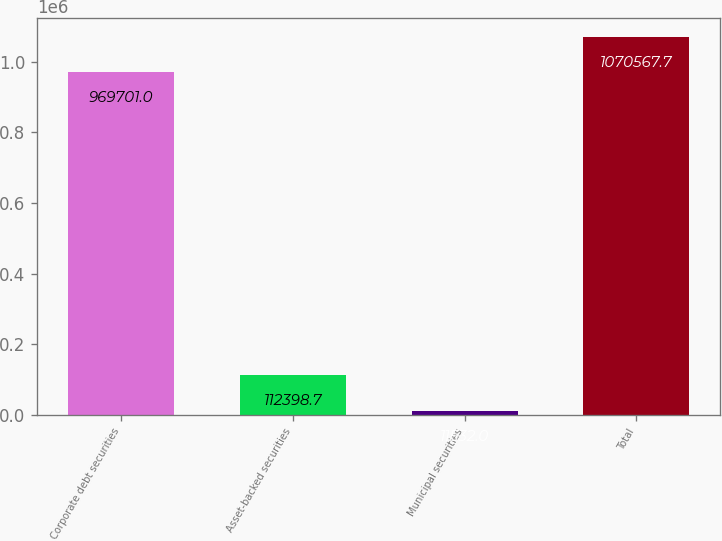Convert chart. <chart><loc_0><loc_0><loc_500><loc_500><bar_chart><fcel>Corporate debt securities<fcel>Asset-backed securities<fcel>Municipal securities<fcel>Total<nl><fcel>969701<fcel>112399<fcel>11532<fcel>1.07057e+06<nl></chart> 